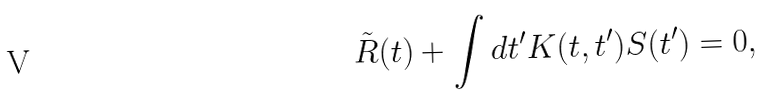Convert formula to latex. <formula><loc_0><loc_0><loc_500><loc_500>\tilde { R } ( t ) + \int d t ^ { \prime } K ( t , t ^ { \prime } ) S ( t ^ { \prime } ) = 0 ,</formula> 